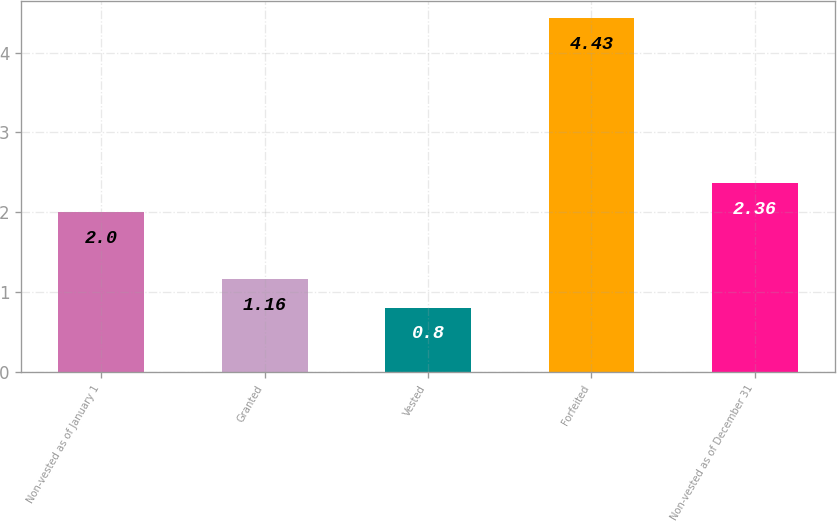Convert chart to OTSL. <chart><loc_0><loc_0><loc_500><loc_500><bar_chart><fcel>Non-vested as of January 1<fcel>Granted<fcel>Vested<fcel>Forfeited<fcel>Non-vested as of December 31<nl><fcel>2<fcel>1.16<fcel>0.8<fcel>4.43<fcel>2.36<nl></chart> 